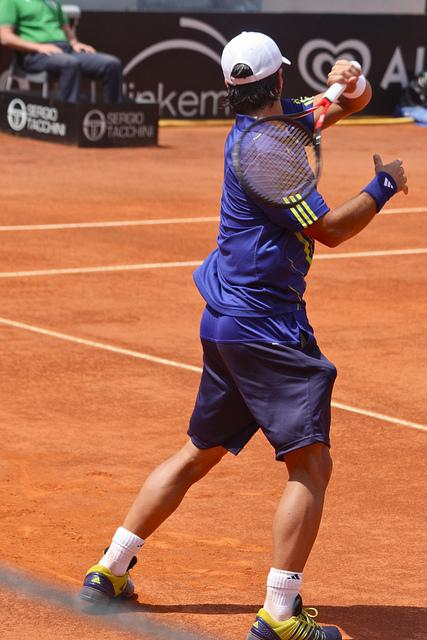What move does this player use? Please explain your reasoning. backhand. The man has the racquet in a backhand move. 